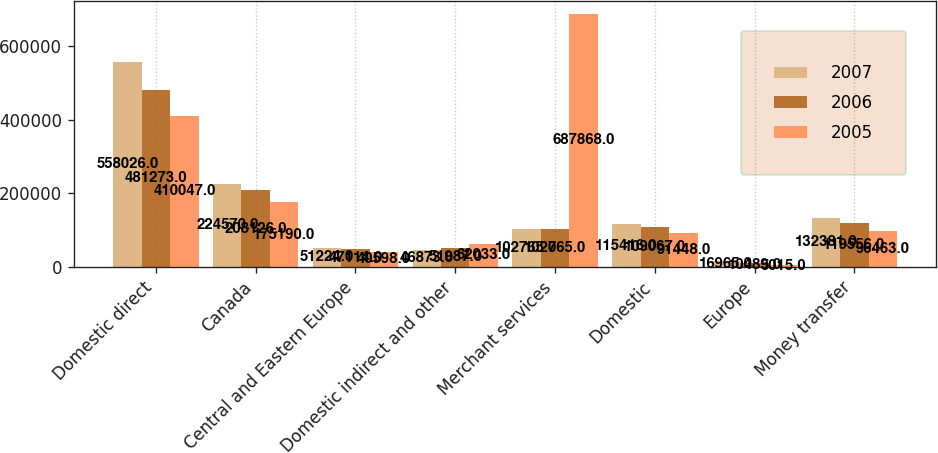Convert chart to OTSL. <chart><loc_0><loc_0><loc_500><loc_500><stacked_bar_chart><ecel><fcel>Domestic direct<fcel>Canada<fcel>Central and Eastern Europe<fcel>Domestic indirect and other<fcel>Merchant services<fcel>Domestic<fcel>Europe<fcel>Money transfer<nl><fcel>2007<fcel>558026<fcel>224570<fcel>51224<fcel>46873<fcel>102765<fcel>115416<fcel>16965<fcel>132381<nl><fcel>2006<fcel>481273<fcel>208126<fcel>47114<fcel>51987<fcel>102765<fcel>109067<fcel>10489<fcel>119556<nl><fcel>2005<fcel>410047<fcel>175190<fcel>40598<fcel>62033<fcel>687868<fcel>91448<fcel>5015<fcel>96463<nl></chart> 